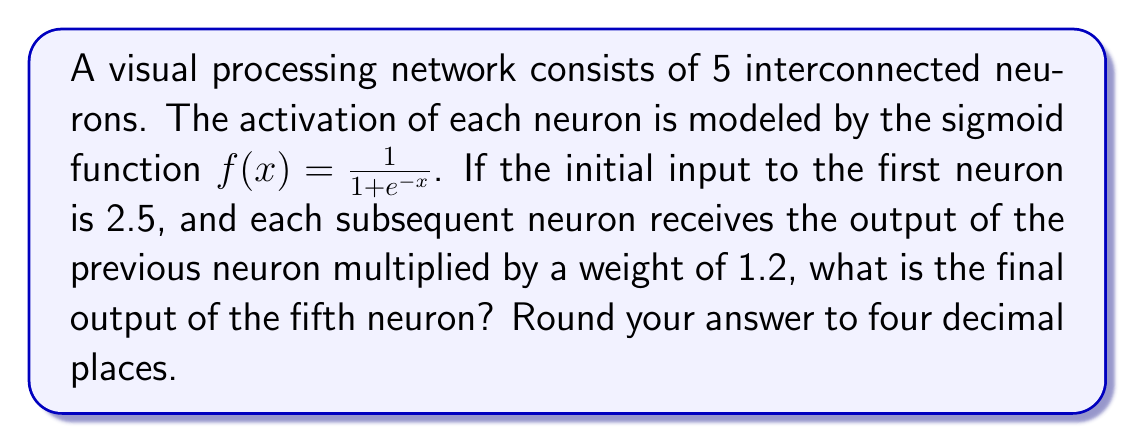Help me with this question. Let's solve this step-by-step:

1) First, we need to calculate the output of each neuron in sequence.

2) For the first neuron:
   Input = 2.5
   Output = $f(2.5) = \frac{1}{1 + e^{-2.5}} = 0.9241$

3) For the second neuron:
   Input = $0.9241 \times 1.2 = 1.1089$
   Output = $f(1.1089) = \frac{1}{1 + e^{-1.1089}} = 0.7518$

4) For the third neuron:
   Input = $0.7518 \times 1.2 = 0.9022$
   Output = $f(0.9022) = \frac{1}{1 + e^{-0.9022}} = 0.7113$

5) For the fourth neuron:
   Input = $0.7113 \times 1.2 = 0.8536$
   Output = $f(0.8536) = \frac{1}{1 + e^{-0.8536}} = 0.7011$

6) For the fifth (final) neuron:
   Input = $0.7011 \times 1.2 = 0.8413$
   Output = $f(0.8413) = \frac{1}{1 + e^{-0.8413}} = 0.6988$

7) Rounding to four decimal places: 0.6988
Answer: 0.6988 